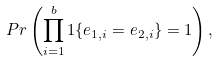Convert formula to latex. <formula><loc_0><loc_0><loc_500><loc_500>P r \left ( \prod _ { i = 1 } ^ { b } 1 \{ e _ { 1 , i } = e _ { 2 , i } \} = 1 \right ) ,</formula> 